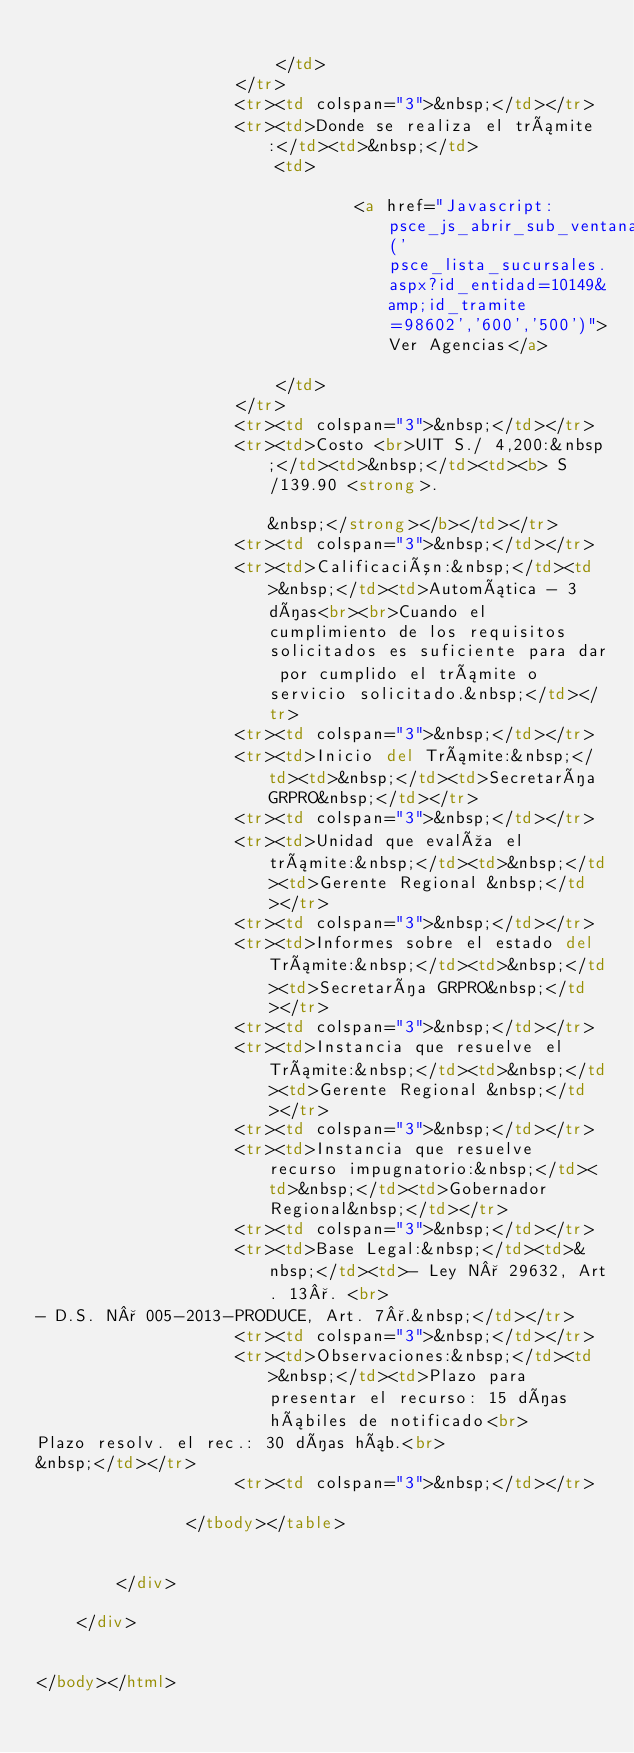<code> <loc_0><loc_0><loc_500><loc_500><_HTML_>                            
                        </td>
                    </tr>
                    <tr><td colspan="3">&nbsp;</td></tr>
                    <tr><td>Donde se realiza el trámite:</td><td>&nbsp;</td>
                        <td>
                            
                                <a href="Javascript: psce_js_abrir_sub_ventanas('psce_lista_sucursales.aspx?id_entidad=10149&amp;id_tramite=98602','600','500')">Ver Agencias</a>
                            
                        </td>
                    </tr>   
                    <tr><td colspan="3">&nbsp;</td></tr>
                    <tr><td>Costo <br>UIT S./ 4,200:&nbsp;</td><td>&nbsp;</td><td><b> S/139.90 <strong>.                                                                                                                                                                                                                                                                                                                                                                                                                                                                                                                                                                                                                                                                                                                                                                                                                                                                                                                                                                                                                                                                                                                                                                                                                                                                                                                                                                                                                                                                                                                                                                                                                                                                                                                                                                                                                                                                                                                                                                                                                                                          &nbsp;</strong></b></td></tr>
                    <tr><td colspan="3">&nbsp;</td></tr>
                    <tr><td>Calificación:&nbsp;</td><td>&nbsp;</td><td>Automática - 3 días<br><br>Cuando el cumplimiento de los requisitos solicitados es suficiente para dar por cumplido el trámite o servicio solicitado.&nbsp;</td></tr>
                    <tr><td colspan="3">&nbsp;</td></tr>
                    <tr><td>Inicio del Trámite:&nbsp;</td><td>&nbsp;</td><td>Secretaría GRPRO&nbsp;</td></tr>
                    <tr><td colspan="3">&nbsp;</td></tr>
                    <tr><td>Unidad que evalúa el trámite:&nbsp;</td><td>&nbsp;</td><td>Gerente Regional &nbsp;</td></tr>
                    <tr><td colspan="3">&nbsp;</td></tr>
                    <tr><td>Informes sobre el estado del Trámite:&nbsp;</td><td>&nbsp;</td><td>Secretaría GRPRO&nbsp;</td></tr>
                    <tr><td colspan="3">&nbsp;</td></tr>
                    <tr><td>Instancia que resuelve el Trámite:&nbsp;</td><td>&nbsp;</td><td>Gerente Regional &nbsp;</td></tr>
                    <tr><td colspan="3">&nbsp;</td></tr>
                    <tr><td>Instancia que resuelve recurso impugnatorio:&nbsp;</td><td>&nbsp;</td><td>Gobernador Regional&nbsp;</td></tr>
                    <tr><td colspan="3">&nbsp;</td></tr>
                    <tr><td>Base Legal:&nbsp;</td><td>&nbsp;</td><td>- Ley N° 29632, Art. 13°. <br>
- D.S. N° 005-2013-PRODUCE, Art. 7°.&nbsp;</td></tr>
                    <tr><td colspan="3">&nbsp;</td></tr>
                    <tr><td>Observaciones:&nbsp;</td><td>&nbsp;</td><td>Plazo para presentar el recurso: 15 días hábiles de notificado<br>
Plazo resolv. el rec.: 30 días háb.<br>
&nbsp;</td></tr>
                    <tr><td colspan="3">&nbsp;</td></tr>

               </tbody></table>
            
            
        </div>

    </div>


</body></html></code> 